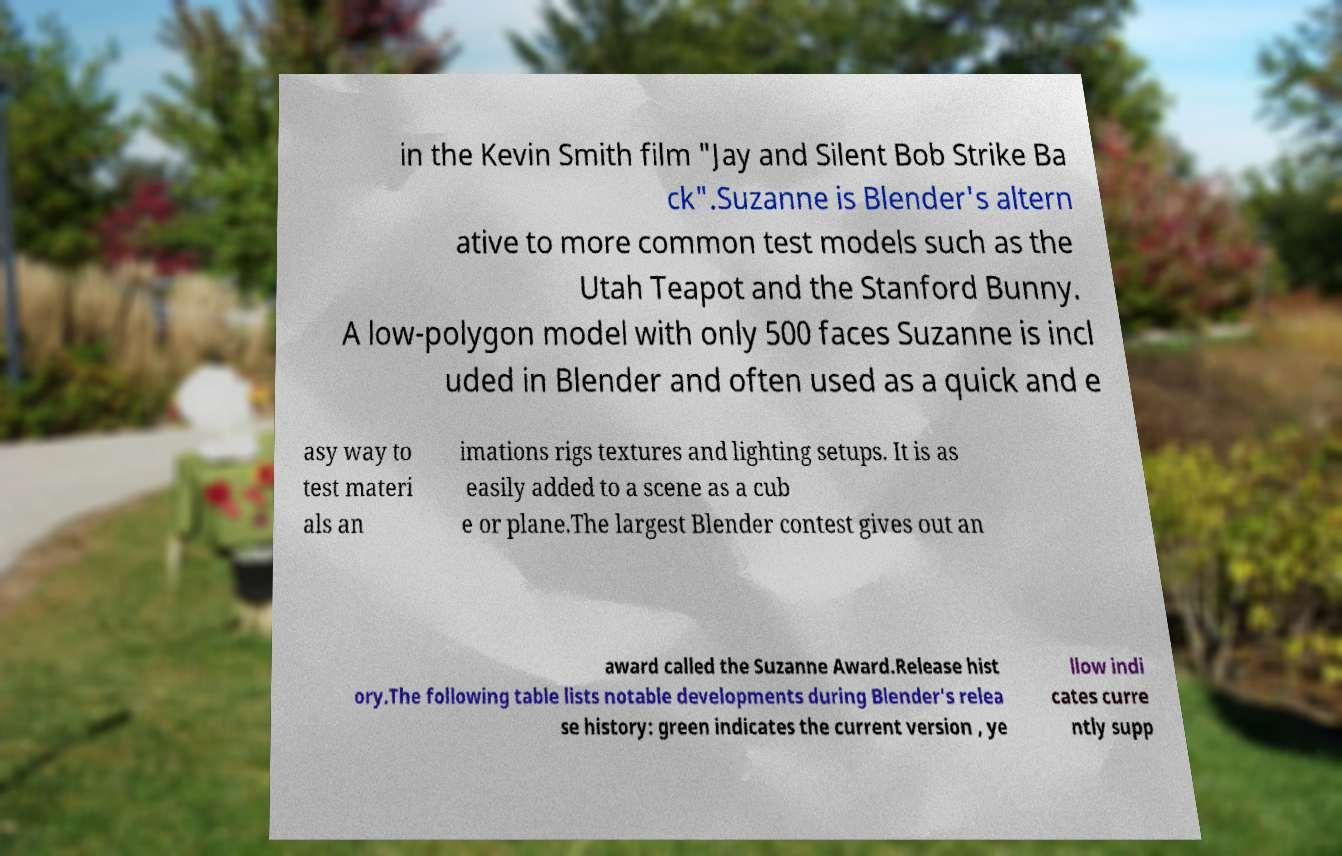Can you read and provide the text displayed in the image?This photo seems to have some interesting text. Can you extract and type it out for me? in the Kevin Smith film "Jay and Silent Bob Strike Ba ck".Suzanne is Blender's altern ative to more common test models such as the Utah Teapot and the Stanford Bunny. A low-polygon model with only 500 faces Suzanne is incl uded in Blender and often used as a quick and e asy way to test materi als an imations rigs textures and lighting setups. It is as easily added to a scene as a cub e or plane.The largest Blender contest gives out an award called the Suzanne Award.Release hist ory.The following table lists notable developments during Blender's relea se history: green indicates the current version , ye llow indi cates curre ntly supp 